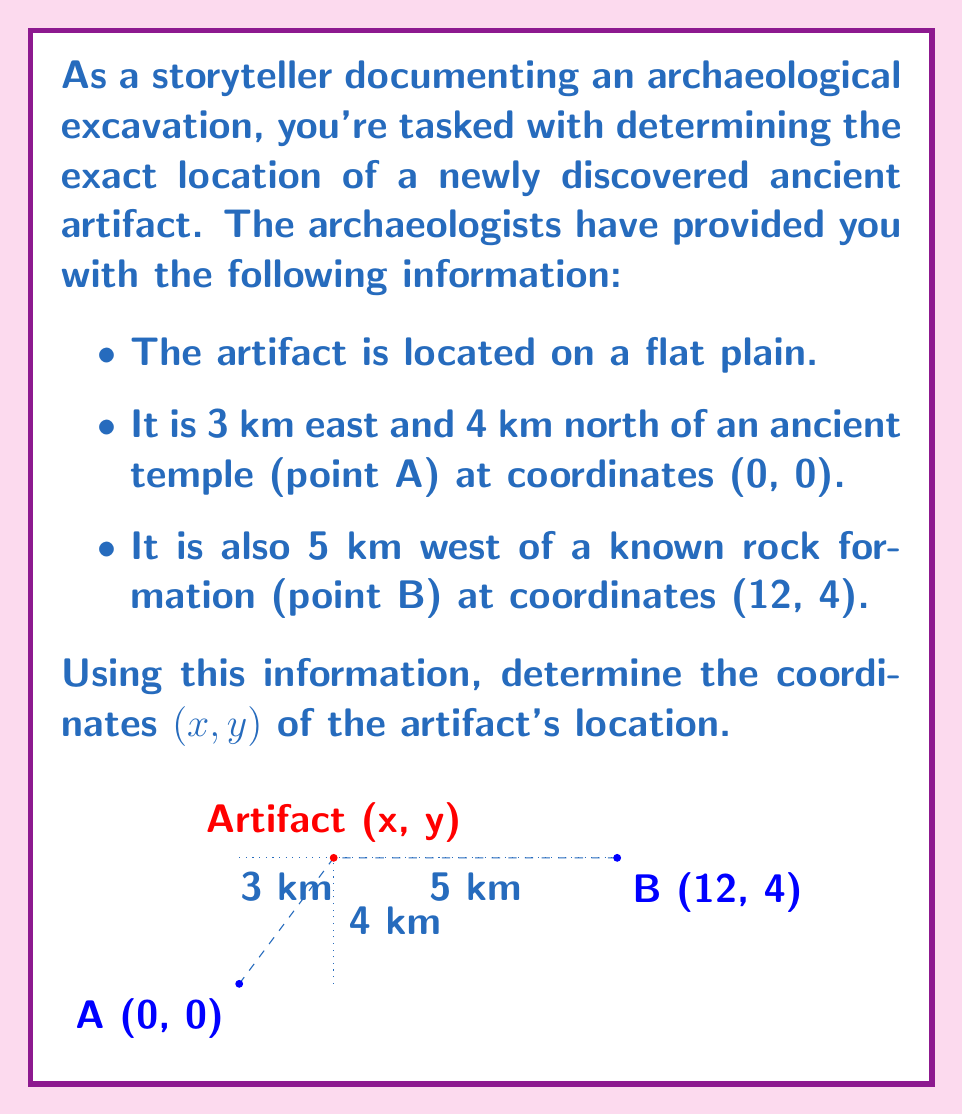Teach me how to tackle this problem. Let's solve this step-by-step:

1) From the given information, we know that the artifact is 3 km east and 4 km north of point A (0, 0). This gives us the y-coordinate of the artifact immediately:

   $y = 0 + 4 = 4$

2) We also know that the x-coordinate is 3 km east of A:

   $x = 0 + 3 = 3$

3) To verify this, we can use the distance formula to check if the artifact is indeed 5 km west of point B (12, 4):

   $$\text{Distance} = \sqrt{(x_2-x_1)^2 + (y_2-y_1)^2}$$

   $$5 = \sqrt{(12-3)^2 + (4-4)^2}$$

   $$5 = \sqrt{9^2 + 0^2} = \sqrt{81} = 9$$

4) This confirms that our coordinates are correct, as the artifact is 5 km west of point B.

Therefore, the coordinates of the artifact are (3, 4).
Answer: (3, 4) 